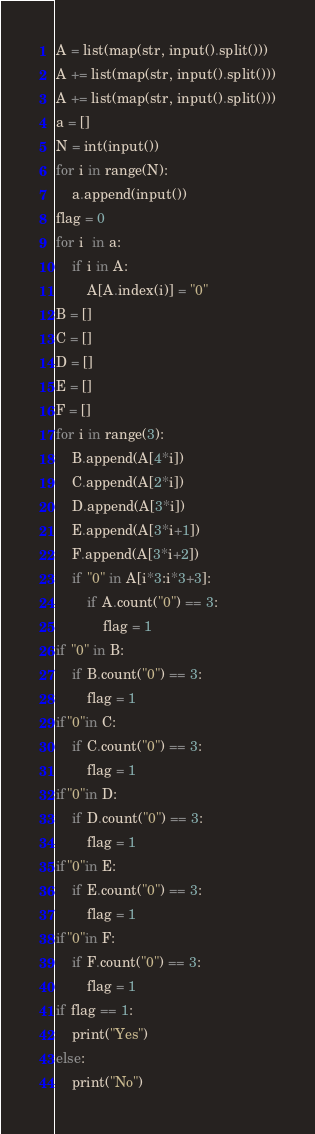<code> <loc_0><loc_0><loc_500><loc_500><_Python_>A = list(map(str, input().split()))
A += list(map(str, input().split()))
A += list(map(str, input().split()))
a = []
N = int(input())
for i in range(N):
    a.append(input())
flag = 0
for i  in a:
    if i in A:
        A[A.index(i)] = "0"
B = []
C = []
D = []
E = []
F = []
for i in range(3):
    B.append(A[4*i])
    C.append(A[2*i])
    D.append(A[3*i])
    E.append(A[3*i+1])
    F.append(A[3*i+2])
    if "0" in A[i*3:i*3+3]:
        if A.count("0") == 3:
            flag = 1
if "0" in B:
    if B.count("0") == 3:
        flag = 1
if"0"in C:
    if C.count("0") == 3:
        flag = 1
if"0"in D:
    if D.count("0") == 3:
        flag = 1
if"0"in E:
    if E.count("0") == 3:
        flag = 1
if"0"in F:
    if F.count("0") == 3:
        flag = 1
if flag == 1:
    print("Yes")
else:
    print("No")</code> 